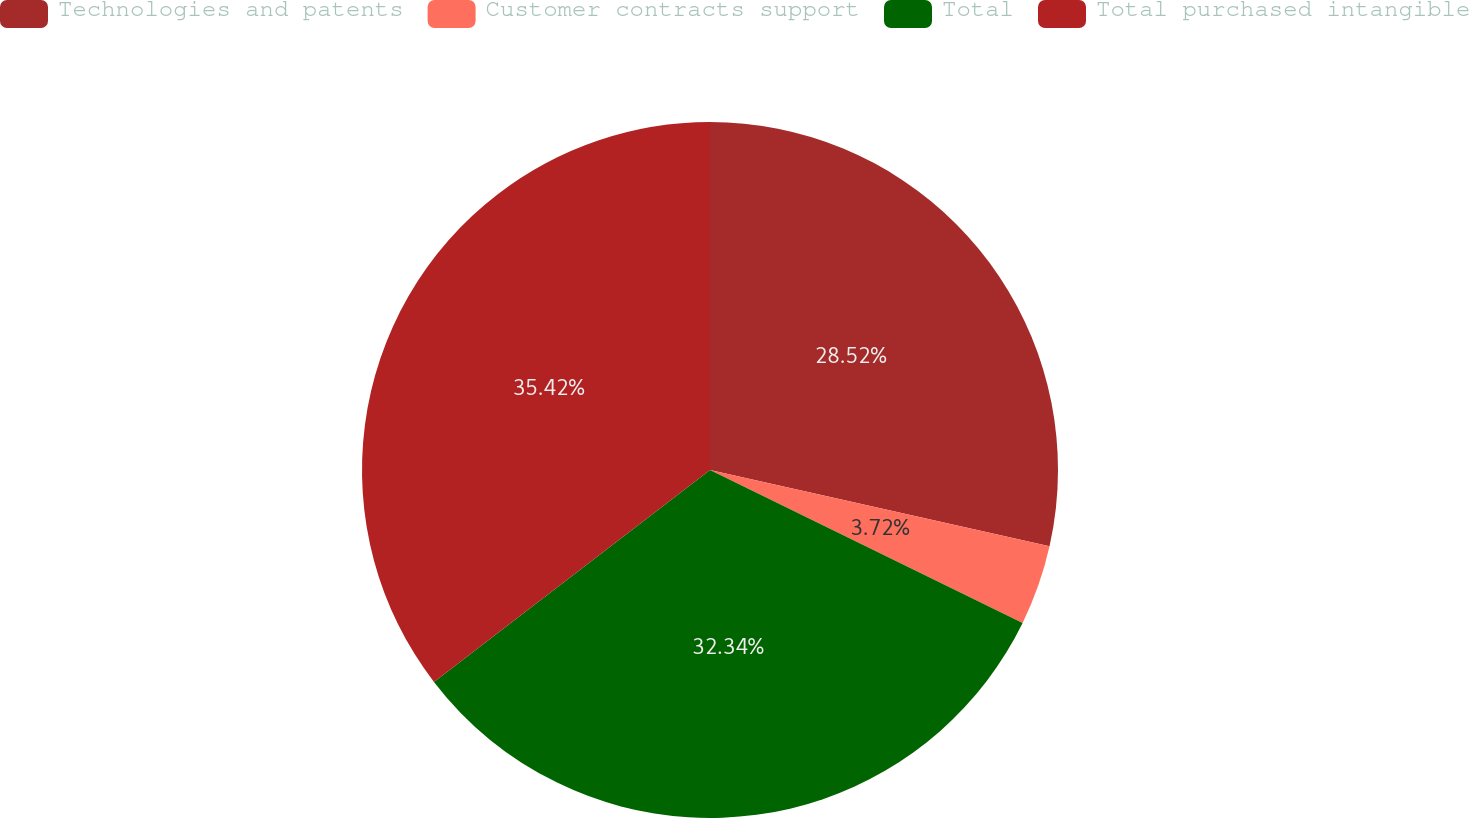Convert chart. <chart><loc_0><loc_0><loc_500><loc_500><pie_chart><fcel>Technologies and patents<fcel>Customer contracts support<fcel>Total<fcel>Total purchased intangible<nl><fcel>28.52%<fcel>3.72%<fcel>32.34%<fcel>35.42%<nl></chart> 